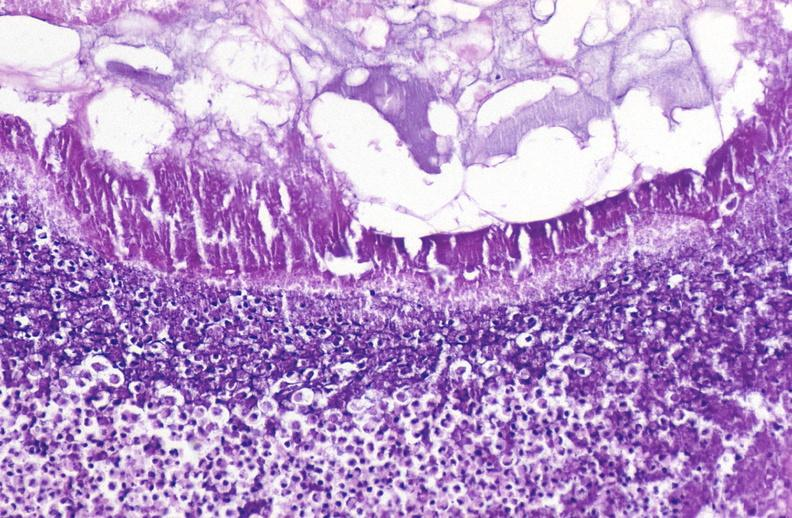where is this?
Answer the question using a single word or phrase. Pancreas 